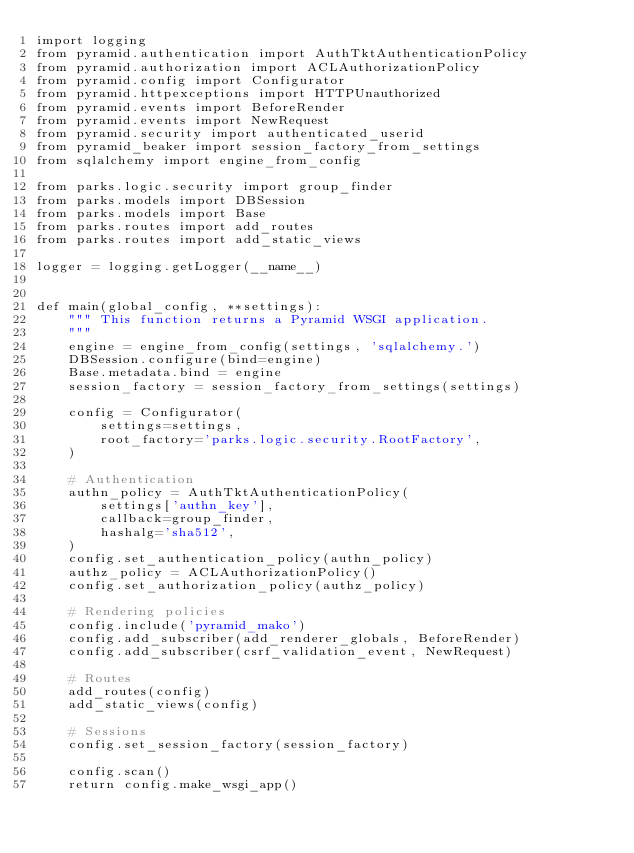Convert code to text. <code><loc_0><loc_0><loc_500><loc_500><_Python_>import logging
from pyramid.authentication import AuthTktAuthenticationPolicy
from pyramid.authorization import ACLAuthorizationPolicy
from pyramid.config import Configurator
from pyramid.httpexceptions import HTTPUnauthorized
from pyramid.events import BeforeRender
from pyramid.events import NewRequest
from pyramid.security import authenticated_userid
from pyramid_beaker import session_factory_from_settings
from sqlalchemy import engine_from_config

from parks.logic.security import group_finder
from parks.models import DBSession
from parks.models import Base
from parks.routes import add_routes
from parks.routes import add_static_views

logger = logging.getLogger(__name__)


def main(global_config, **settings):
    """ This function returns a Pyramid WSGI application.
    """
    engine = engine_from_config(settings, 'sqlalchemy.')
    DBSession.configure(bind=engine)
    Base.metadata.bind = engine
    session_factory = session_factory_from_settings(settings)

    config = Configurator(
        settings=settings,
        root_factory='parks.logic.security.RootFactory',
    )

    # Authentication
    authn_policy = AuthTktAuthenticationPolicy(
        settings['authn_key'],
        callback=group_finder,
        hashalg='sha512',
    )
    config.set_authentication_policy(authn_policy)
    authz_policy = ACLAuthorizationPolicy()
    config.set_authorization_policy(authz_policy)

    # Rendering policies
    config.include('pyramid_mako')
    config.add_subscriber(add_renderer_globals, BeforeRender)
    config.add_subscriber(csrf_validation_event, NewRequest)

    # Routes
    add_routes(config)
    add_static_views(config)

    # Sessions
    config.set_session_factory(session_factory)

    config.scan()
    return config.make_wsgi_app()

</code> 